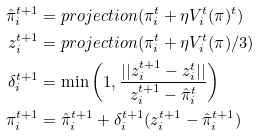Convert formula to latex. <formula><loc_0><loc_0><loc_500><loc_500>\hat { \pi } _ { i } ^ { t + 1 } & = p r o j e c t i o n ( \pi _ { i } ^ { t } + \eta V _ { i } ^ { t } ( \pi ) ^ { t } ) \\ z _ { i } ^ { t + 1 } & = p r o j e c t i o n ( \pi _ { i } ^ { t } + \eta V _ { i } ^ { t } ( \pi ) / 3 ) \\ \delta _ { i } ^ { t + 1 } & = \min \left ( 1 , \frac { | | z _ { i } ^ { t + 1 } - z _ { i } ^ { t } | | } { z _ { i } ^ { t + 1 } - \hat { \pi } _ { i } ^ { t } } \right ) \\ \pi _ { i } ^ { t + 1 } & = \hat { \pi } _ { i } ^ { t + 1 } + \delta _ { i } ^ { t + 1 } ( z _ { i } ^ { t + 1 } - \hat { \pi } _ { i } ^ { t + 1 } )</formula> 